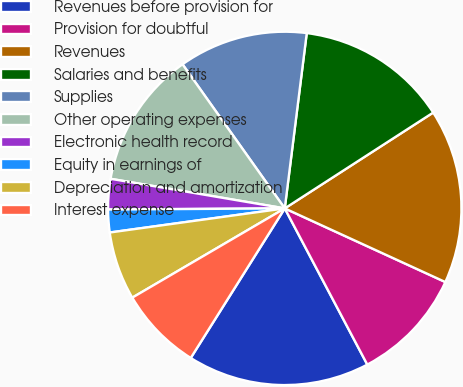Convert chart to OTSL. <chart><loc_0><loc_0><loc_500><loc_500><pie_chart><fcel>Revenues before provision for<fcel>Provision for doubtful<fcel>Revenues<fcel>Salaries and benefits<fcel>Supplies<fcel>Other operating expenses<fcel>Electronic health record<fcel>Equity in earnings of<fcel>Depreciation and amortization<fcel>Interest expense<nl><fcel>16.67%<fcel>10.42%<fcel>15.97%<fcel>13.89%<fcel>11.81%<fcel>12.5%<fcel>2.78%<fcel>2.08%<fcel>6.25%<fcel>7.64%<nl></chart> 